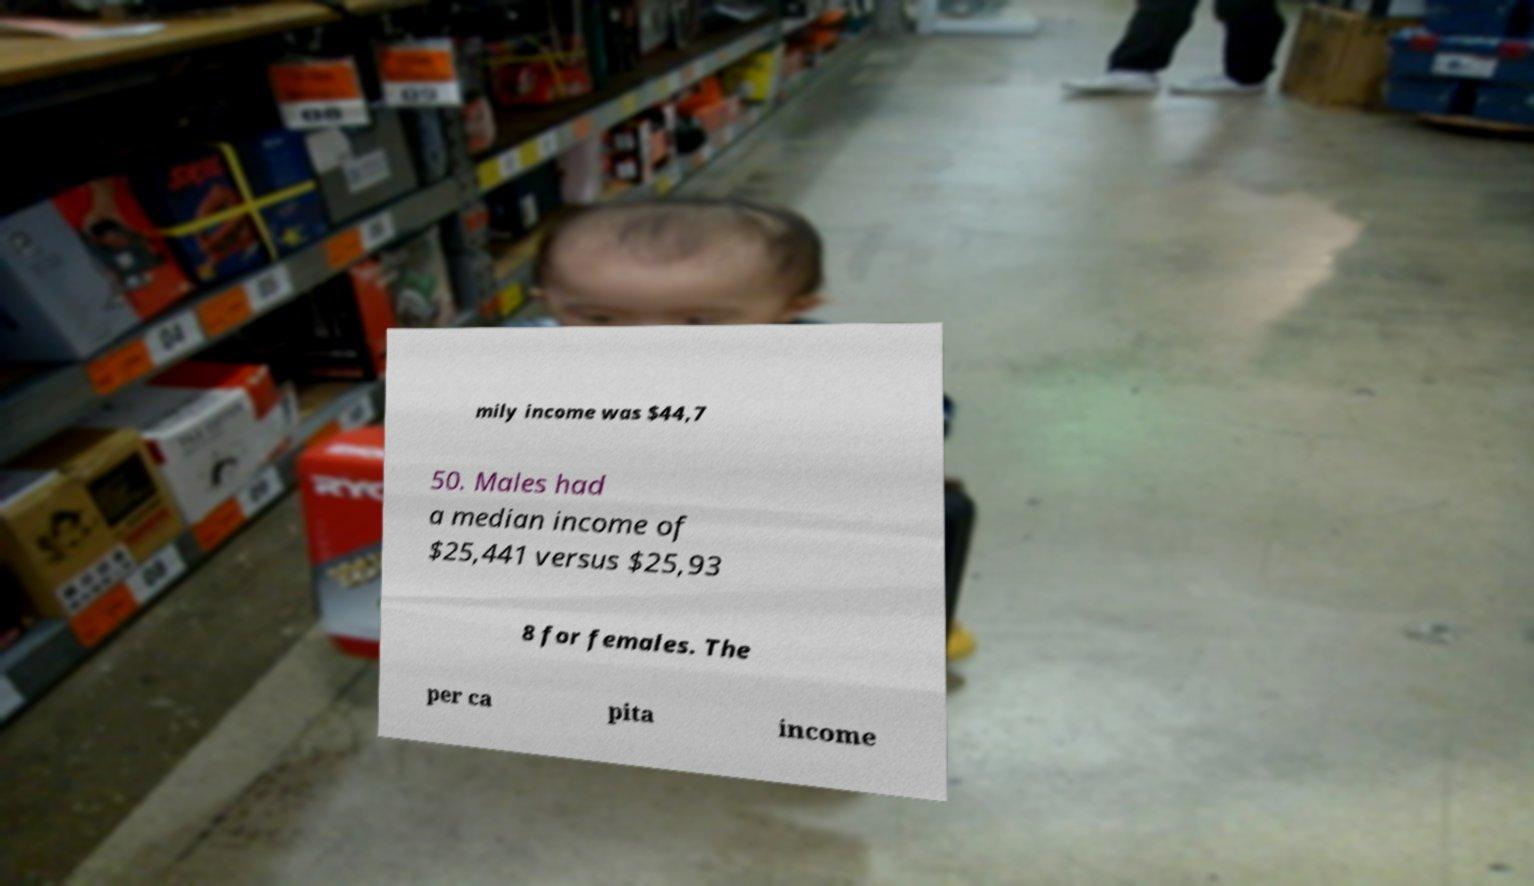Can you read and provide the text displayed in the image?This photo seems to have some interesting text. Can you extract and type it out for me? mily income was $44,7 50. Males had a median income of $25,441 versus $25,93 8 for females. The per ca pita income 